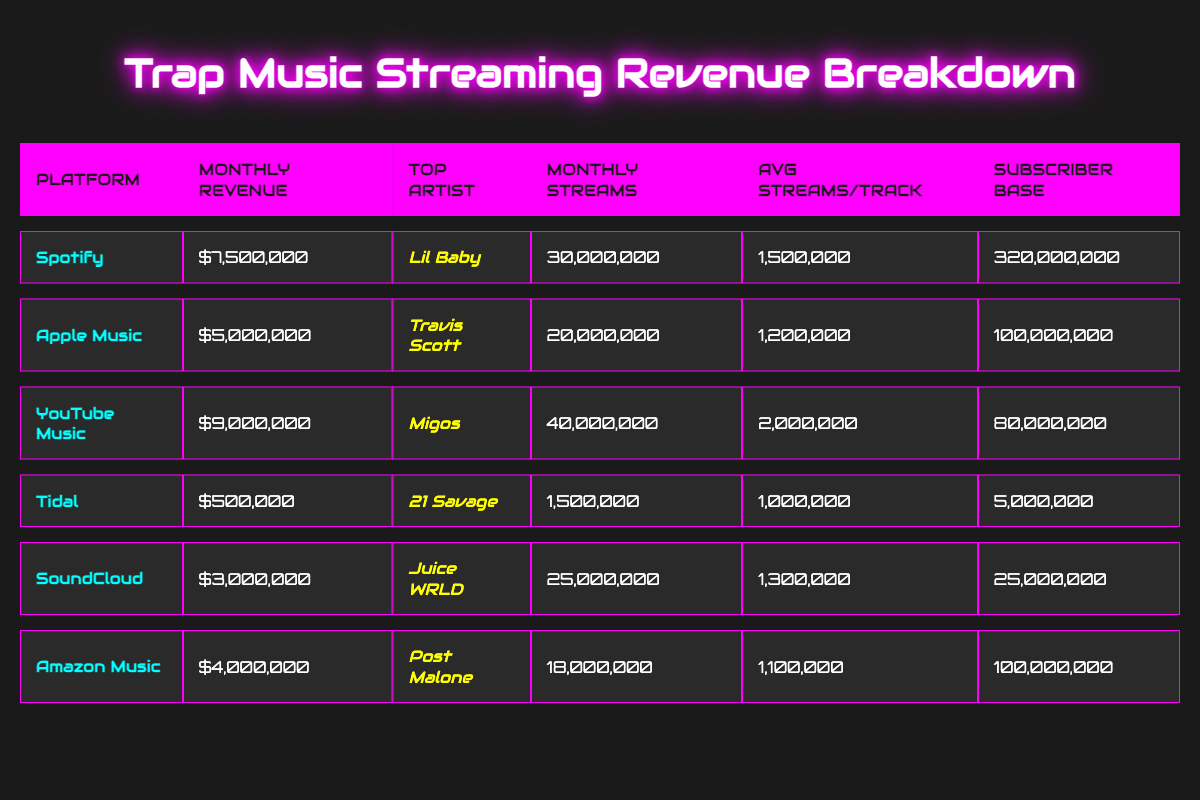What is the monthly revenue for YouTube Music? In the table, the entry for YouTube Music lists the monthly revenue as $9,000,000. Therefore, by directly referring to that entry, we find the answer.
Answer: $9,000,000 Which platform has the highest subscriber base? Looking through the subscriber base column, Spotify has the highest number at 320,000,000. Therefore, by comparison of all platforms listed, we can conclude that Spotify has the most subscribers.
Answer: Spotify How many more monthly streams does Migos have than Lil Baby? Migos has 40,000,000 monthly streams, while Lil Baby has 30,000,000 monthly streams. To find the difference, subtract Lil Baby's streams from Migos' streams: 40,000,000 - 30,000,000 = 10,000,000.
Answer: 10,000,000 What is the total monthly revenue from all platforms listed? Adding the monthly revenue for each platform: $7,500,000 (Spotify) + $5,000,000 (Apple Music) + $9,000,000 (YouTube Music) + $500,000 (Tidal) + $3,000,000 (SoundCloud) + $4,000,000 (Amazon Music) = $29,000,000. Therefore, we combine all these revenues to get the total.
Answer: $29,000,000 Is the average streams per track higher on SoundCloud than on Tidal? The average streams per track for SoundCloud is 1,300,000 and for Tidal it is 1,000,000. Since 1,300,000 is greater than 1,000,000, the statement is true.
Answer: Yes How many subscribers does Apple Music have compared to SoundCloud? Apple Music has 100,000,000 subscribers, while SoundCloud has 25,000,000. To find how many more subscribers Apple Music has, we subtract SoundCloud's subscribers from Apple Music's: 100,000,000 - 25,000,000 = 75,000,000. Therefore, Apple Music has significantly more.
Answer: 75,000,000 Which artist is the top artist for the platform that has the least monthly revenue? Tidal has the least monthly revenue of $500,000, and the top artist listed for Tidal is 21 Savage. Thus, by identifying Tidal as having the lowest revenue, we find its top artist.
Answer: 21 Savage What is the average monthly revenue of the listed platforms? The total monthly revenue from all platforms is $29,000,000. There are 6 platforms in total. To find the average, we divide the total revenue by the number of platforms: $29,000,000 / 6 = $4,833,333.33. Therefore, we calculate this to find the average.
Answer: $4,833,333.33 